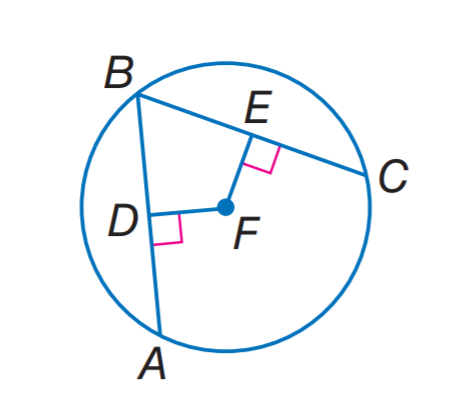Answer the mathemtical geometry problem and directly provide the correct option letter.
Question: In \odot F, A B \cong B C, D F = 3 x - 7, and F E = x + 9. What is x?
Choices: A: 4 B: 7 C: 8 D: 9 C 